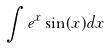<formula> <loc_0><loc_0><loc_500><loc_500>\int e ^ { x } \sin ( x ) d x</formula> 